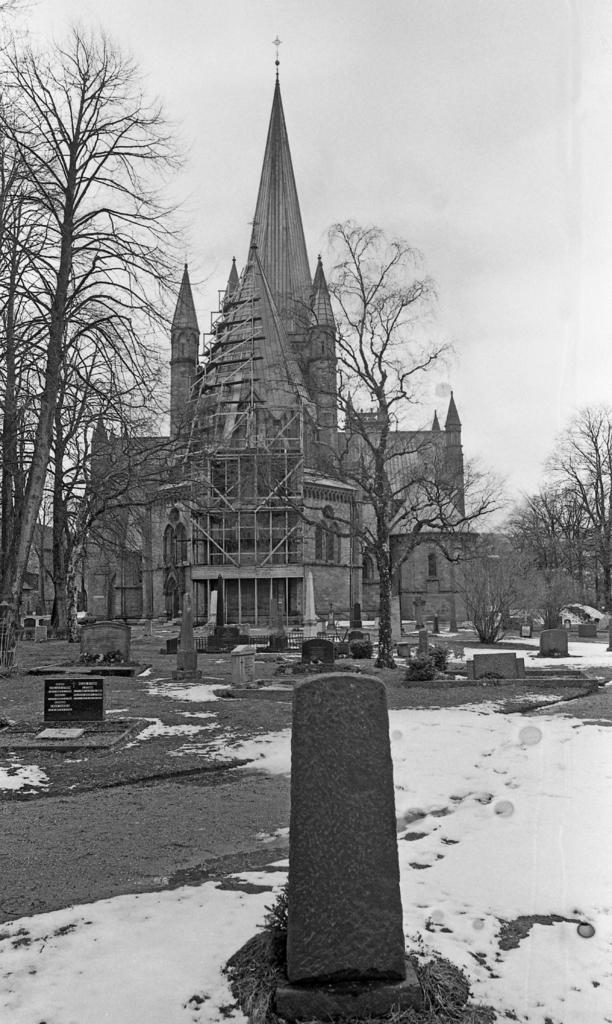What type of structures can be seen in the image? There are monuments in the image. What is the weather like in the image? There is snow visible in the image, indicating a cold or wintery setting. What type of vegetation is present in the image? There are trees in the image. What type of building can be seen in the image? There is a building in the image. What architectural feature is visible on the building? There are windows in the image. Can you see a sack of potatoes near the monuments in the image? There is no sack of potatoes present in the image. Is there a stream visible in the image? There is no stream visible in the image; the image only shows snow, trees, monuments, a building, and windows. --- Facts: 1. There is a person holding a book in the image. 2. The person is sitting on a chair. 3. There is a table in the image. 4. The table has a lamp on it. 5. The background of the image is a wall. Absurd Topics: parrot, sand, bicycle Conversation: What is the person in the image holding? The person is holding a book in the image. What is the person sitting on? The person is sitting on a chair. What type of furniture is present in the image? There is a table in the image. What is on the table? The table has a lamp on it. What can be seen behind the person? The background of the image is a wall. Reasoning: Let's think step by step in order to produce the conversation. We start by identifying the main subject in the image, which is the person holding a book. Then, we expand the conversation to include other items that are also visible, such as the chair, table, lamp, and wall. Each question is designed to elicit a specific detail about the image that is known from the provided facts. Absurd Question/Answer: Can you see a parrot perched on the lamp in the image? There is no parrot present in the image; the image only shows a person holding a book, a chair, a table, a lamp, and a wall. Is there any sand visible in the image? There is no sand visible in the image; the image only shows a person holding a book, a chair, a table, a lamp, and a wall. 